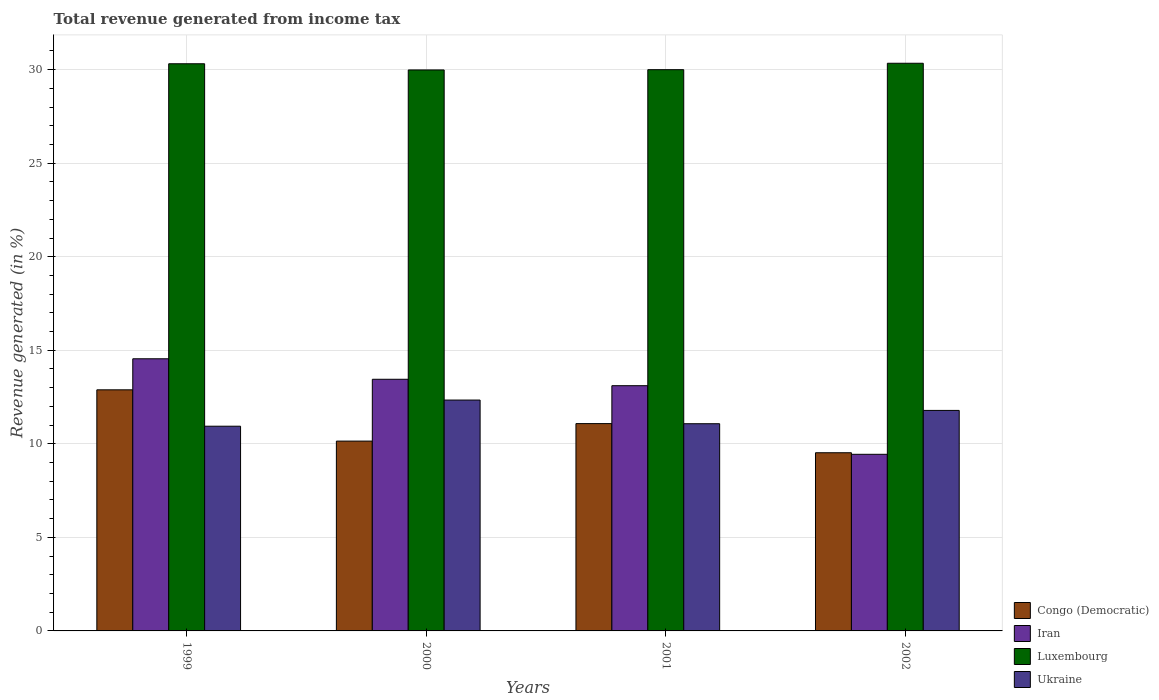How many groups of bars are there?
Your answer should be very brief. 4. Are the number of bars per tick equal to the number of legend labels?
Your answer should be compact. Yes. Are the number of bars on each tick of the X-axis equal?
Your answer should be compact. Yes. What is the label of the 1st group of bars from the left?
Provide a short and direct response. 1999. What is the total revenue generated in Luxembourg in 2002?
Your answer should be very brief. 30.34. Across all years, what is the maximum total revenue generated in Congo (Democratic)?
Your response must be concise. 12.89. Across all years, what is the minimum total revenue generated in Ukraine?
Offer a very short reply. 10.94. In which year was the total revenue generated in Ukraine maximum?
Offer a terse response. 2000. What is the total total revenue generated in Ukraine in the graph?
Provide a short and direct response. 46.14. What is the difference between the total revenue generated in Iran in 1999 and that in 2002?
Ensure brevity in your answer.  5.11. What is the difference between the total revenue generated in Iran in 2000 and the total revenue generated in Congo (Democratic) in 1999?
Provide a succinct answer. 0.56. What is the average total revenue generated in Congo (Democratic) per year?
Your answer should be very brief. 10.91. In the year 1999, what is the difference between the total revenue generated in Iran and total revenue generated in Luxembourg?
Give a very brief answer. -15.77. In how many years, is the total revenue generated in Luxembourg greater than 15 %?
Offer a very short reply. 4. What is the ratio of the total revenue generated in Iran in 2001 to that in 2002?
Give a very brief answer. 1.39. Is the total revenue generated in Luxembourg in 2000 less than that in 2001?
Your answer should be very brief. Yes. Is the difference between the total revenue generated in Iran in 2000 and 2002 greater than the difference between the total revenue generated in Luxembourg in 2000 and 2002?
Offer a very short reply. Yes. What is the difference between the highest and the second highest total revenue generated in Luxembourg?
Your answer should be compact. 0.03. What is the difference between the highest and the lowest total revenue generated in Iran?
Provide a short and direct response. 5.11. Is the sum of the total revenue generated in Luxembourg in 2000 and 2001 greater than the maximum total revenue generated in Iran across all years?
Provide a succinct answer. Yes. What does the 2nd bar from the left in 1999 represents?
Ensure brevity in your answer.  Iran. What does the 3rd bar from the right in 2002 represents?
Offer a very short reply. Iran. Are all the bars in the graph horizontal?
Provide a short and direct response. No. How many years are there in the graph?
Offer a terse response. 4. Where does the legend appear in the graph?
Give a very brief answer. Bottom right. How many legend labels are there?
Provide a short and direct response. 4. What is the title of the graph?
Your answer should be very brief. Total revenue generated from income tax. Does "Guinea" appear as one of the legend labels in the graph?
Provide a succinct answer. No. What is the label or title of the X-axis?
Provide a short and direct response. Years. What is the label or title of the Y-axis?
Offer a terse response. Revenue generated (in %). What is the Revenue generated (in %) of Congo (Democratic) in 1999?
Your answer should be very brief. 12.89. What is the Revenue generated (in %) of Iran in 1999?
Your answer should be very brief. 14.55. What is the Revenue generated (in %) in Luxembourg in 1999?
Provide a short and direct response. 30.32. What is the Revenue generated (in %) of Ukraine in 1999?
Ensure brevity in your answer.  10.94. What is the Revenue generated (in %) in Congo (Democratic) in 2000?
Your answer should be compact. 10.15. What is the Revenue generated (in %) of Iran in 2000?
Your answer should be compact. 13.45. What is the Revenue generated (in %) of Luxembourg in 2000?
Your response must be concise. 29.98. What is the Revenue generated (in %) in Ukraine in 2000?
Make the answer very short. 12.34. What is the Revenue generated (in %) of Congo (Democratic) in 2001?
Provide a succinct answer. 11.08. What is the Revenue generated (in %) in Iran in 2001?
Provide a succinct answer. 13.11. What is the Revenue generated (in %) of Luxembourg in 2001?
Provide a short and direct response. 30. What is the Revenue generated (in %) of Ukraine in 2001?
Provide a short and direct response. 11.07. What is the Revenue generated (in %) of Congo (Democratic) in 2002?
Give a very brief answer. 9.52. What is the Revenue generated (in %) in Iran in 2002?
Offer a very short reply. 9.44. What is the Revenue generated (in %) in Luxembourg in 2002?
Offer a very short reply. 30.34. What is the Revenue generated (in %) in Ukraine in 2002?
Give a very brief answer. 11.79. Across all years, what is the maximum Revenue generated (in %) of Congo (Democratic)?
Offer a very short reply. 12.89. Across all years, what is the maximum Revenue generated (in %) in Iran?
Offer a very short reply. 14.55. Across all years, what is the maximum Revenue generated (in %) of Luxembourg?
Give a very brief answer. 30.34. Across all years, what is the maximum Revenue generated (in %) in Ukraine?
Offer a very short reply. 12.34. Across all years, what is the minimum Revenue generated (in %) of Congo (Democratic)?
Provide a succinct answer. 9.52. Across all years, what is the minimum Revenue generated (in %) in Iran?
Your response must be concise. 9.44. Across all years, what is the minimum Revenue generated (in %) of Luxembourg?
Keep it short and to the point. 29.98. Across all years, what is the minimum Revenue generated (in %) of Ukraine?
Provide a short and direct response. 10.94. What is the total Revenue generated (in %) of Congo (Democratic) in the graph?
Ensure brevity in your answer.  43.64. What is the total Revenue generated (in %) of Iran in the graph?
Ensure brevity in your answer.  50.54. What is the total Revenue generated (in %) in Luxembourg in the graph?
Provide a succinct answer. 120.64. What is the total Revenue generated (in %) of Ukraine in the graph?
Keep it short and to the point. 46.14. What is the difference between the Revenue generated (in %) of Congo (Democratic) in 1999 and that in 2000?
Your response must be concise. 2.74. What is the difference between the Revenue generated (in %) of Iran in 1999 and that in 2000?
Provide a succinct answer. 1.1. What is the difference between the Revenue generated (in %) of Luxembourg in 1999 and that in 2000?
Make the answer very short. 0.33. What is the difference between the Revenue generated (in %) of Ukraine in 1999 and that in 2000?
Give a very brief answer. -1.4. What is the difference between the Revenue generated (in %) in Congo (Democratic) in 1999 and that in 2001?
Give a very brief answer. 1.81. What is the difference between the Revenue generated (in %) in Iran in 1999 and that in 2001?
Your answer should be very brief. 1.44. What is the difference between the Revenue generated (in %) in Luxembourg in 1999 and that in 2001?
Offer a terse response. 0.32. What is the difference between the Revenue generated (in %) of Ukraine in 1999 and that in 2001?
Your answer should be compact. -0.13. What is the difference between the Revenue generated (in %) in Congo (Democratic) in 1999 and that in 2002?
Offer a terse response. 3.36. What is the difference between the Revenue generated (in %) in Iran in 1999 and that in 2002?
Your response must be concise. 5.11. What is the difference between the Revenue generated (in %) of Luxembourg in 1999 and that in 2002?
Provide a succinct answer. -0.03. What is the difference between the Revenue generated (in %) in Ukraine in 1999 and that in 2002?
Offer a very short reply. -0.84. What is the difference between the Revenue generated (in %) in Congo (Democratic) in 2000 and that in 2001?
Make the answer very short. -0.94. What is the difference between the Revenue generated (in %) in Iran in 2000 and that in 2001?
Give a very brief answer. 0.34. What is the difference between the Revenue generated (in %) of Luxembourg in 2000 and that in 2001?
Ensure brevity in your answer.  -0.01. What is the difference between the Revenue generated (in %) in Ukraine in 2000 and that in 2001?
Offer a very short reply. 1.27. What is the difference between the Revenue generated (in %) of Congo (Democratic) in 2000 and that in 2002?
Your answer should be compact. 0.62. What is the difference between the Revenue generated (in %) of Iran in 2000 and that in 2002?
Offer a terse response. 4.01. What is the difference between the Revenue generated (in %) of Luxembourg in 2000 and that in 2002?
Make the answer very short. -0.36. What is the difference between the Revenue generated (in %) in Ukraine in 2000 and that in 2002?
Provide a succinct answer. 0.55. What is the difference between the Revenue generated (in %) of Congo (Democratic) in 2001 and that in 2002?
Offer a very short reply. 1.56. What is the difference between the Revenue generated (in %) in Iran in 2001 and that in 2002?
Give a very brief answer. 3.67. What is the difference between the Revenue generated (in %) in Luxembourg in 2001 and that in 2002?
Your answer should be very brief. -0.34. What is the difference between the Revenue generated (in %) of Ukraine in 2001 and that in 2002?
Your answer should be very brief. -0.71. What is the difference between the Revenue generated (in %) of Congo (Democratic) in 1999 and the Revenue generated (in %) of Iran in 2000?
Give a very brief answer. -0.56. What is the difference between the Revenue generated (in %) in Congo (Democratic) in 1999 and the Revenue generated (in %) in Luxembourg in 2000?
Keep it short and to the point. -17.1. What is the difference between the Revenue generated (in %) of Congo (Democratic) in 1999 and the Revenue generated (in %) of Ukraine in 2000?
Offer a terse response. 0.55. What is the difference between the Revenue generated (in %) in Iran in 1999 and the Revenue generated (in %) in Luxembourg in 2000?
Give a very brief answer. -15.44. What is the difference between the Revenue generated (in %) of Iran in 1999 and the Revenue generated (in %) of Ukraine in 2000?
Offer a very short reply. 2.21. What is the difference between the Revenue generated (in %) of Luxembourg in 1999 and the Revenue generated (in %) of Ukraine in 2000?
Provide a succinct answer. 17.97. What is the difference between the Revenue generated (in %) in Congo (Democratic) in 1999 and the Revenue generated (in %) in Iran in 2001?
Keep it short and to the point. -0.22. What is the difference between the Revenue generated (in %) in Congo (Democratic) in 1999 and the Revenue generated (in %) in Luxembourg in 2001?
Give a very brief answer. -17.11. What is the difference between the Revenue generated (in %) in Congo (Democratic) in 1999 and the Revenue generated (in %) in Ukraine in 2001?
Give a very brief answer. 1.81. What is the difference between the Revenue generated (in %) in Iran in 1999 and the Revenue generated (in %) in Luxembourg in 2001?
Your answer should be very brief. -15.45. What is the difference between the Revenue generated (in %) of Iran in 1999 and the Revenue generated (in %) of Ukraine in 2001?
Your response must be concise. 3.47. What is the difference between the Revenue generated (in %) of Luxembourg in 1999 and the Revenue generated (in %) of Ukraine in 2001?
Ensure brevity in your answer.  19.24. What is the difference between the Revenue generated (in %) in Congo (Democratic) in 1999 and the Revenue generated (in %) in Iran in 2002?
Your answer should be very brief. 3.45. What is the difference between the Revenue generated (in %) of Congo (Democratic) in 1999 and the Revenue generated (in %) of Luxembourg in 2002?
Make the answer very short. -17.45. What is the difference between the Revenue generated (in %) in Congo (Democratic) in 1999 and the Revenue generated (in %) in Ukraine in 2002?
Your response must be concise. 1.1. What is the difference between the Revenue generated (in %) in Iran in 1999 and the Revenue generated (in %) in Luxembourg in 2002?
Your answer should be very brief. -15.8. What is the difference between the Revenue generated (in %) in Iran in 1999 and the Revenue generated (in %) in Ukraine in 2002?
Make the answer very short. 2.76. What is the difference between the Revenue generated (in %) of Luxembourg in 1999 and the Revenue generated (in %) of Ukraine in 2002?
Your answer should be very brief. 18.53. What is the difference between the Revenue generated (in %) of Congo (Democratic) in 2000 and the Revenue generated (in %) of Iran in 2001?
Your answer should be very brief. -2.96. What is the difference between the Revenue generated (in %) in Congo (Democratic) in 2000 and the Revenue generated (in %) in Luxembourg in 2001?
Your answer should be very brief. -19.85. What is the difference between the Revenue generated (in %) in Congo (Democratic) in 2000 and the Revenue generated (in %) in Ukraine in 2001?
Your response must be concise. -0.93. What is the difference between the Revenue generated (in %) in Iran in 2000 and the Revenue generated (in %) in Luxembourg in 2001?
Your answer should be compact. -16.55. What is the difference between the Revenue generated (in %) of Iran in 2000 and the Revenue generated (in %) of Ukraine in 2001?
Provide a succinct answer. 2.38. What is the difference between the Revenue generated (in %) of Luxembourg in 2000 and the Revenue generated (in %) of Ukraine in 2001?
Give a very brief answer. 18.91. What is the difference between the Revenue generated (in %) of Congo (Democratic) in 2000 and the Revenue generated (in %) of Iran in 2002?
Give a very brief answer. 0.71. What is the difference between the Revenue generated (in %) in Congo (Democratic) in 2000 and the Revenue generated (in %) in Luxembourg in 2002?
Make the answer very short. -20.2. What is the difference between the Revenue generated (in %) in Congo (Democratic) in 2000 and the Revenue generated (in %) in Ukraine in 2002?
Provide a succinct answer. -1.64. What is the difference between the Revenue generated (in %) of Iran in 2000 and the Revenue generated (in %) of Luxembourg in 2002?
Give a very brief answer. -16.89. What is the difference between the Revenue generated (in %) in Iran in 2000 and the Revenue generated (in %) in Ukraine in 2002?
Offer a very short reply. 1.66. What is the difference between the Revenue generated (in %) of Luxembourg in 2000 and the Revenue generated (in %) of Ukraine in 2002?
Provide a short and direct response. 18.2. What is the difference between the Revenue generated (in %) of Congo (Democratic) in 2001 and the Revenue generated (in %) of Iran in 2002?
Keep it short and to the point. 1.64. What is the difference between the Revenue generated (in %) in Congo (Democratic) in 2001 and the Revenue generated (in %) in Luxembourg in 2002?
Make the answer very short. -19.26. What is the difference between the Revenue generated (in %) of Congo (Democratic) in 2001 and the Revenue generated (in %) of Ukraine in 2002?
Keep it short and to the point. -0.71. What is the difference between the Revenue generated (in %) in Iran in 2001 and the Revenue generated (in %) in Luxembourg in 2002?
Provide a short and direct response. -17.23. What is the difference between the Revenue generated (in %) in Iran in 2001 and the Revenue generated (in %) in Ukraine in 2002?
Keep it short and to the point. 1.32. What is the difference between the Revenue generated (in %) of Luxembourg in 2001 and the Revenue generated (in %) of Ukraine in 2002?
Provide a succinct answer. 18.21. What is the average Revenue generated (in %) of Congo (Democratic) per year?
Your response must be concise. 10.91. What is the average Revenue generated (in %) in Iran per year?
Provide a short and direct response. 12.64. What is the average Revenue generated (in %) in Luxembourg per year?
Ensure brevity in your answer.  30.16. What is the average Revenue generated (in %) in Ukraine per year?
Your response must be concise. 11.54. In the year 1999, what is the difference between the Revenue generated (in %) of Congo (Democratic) and Revenue generated (in %) of Iran?
Ensure brevity in your answer.  -1.66. In the year 1999, what is the difference between the Revenue generated (in %) in Congo (Democratic) and Revenue generated (in %) in Luxembourg?
Offer a very short reply. -17.43. In the year 1999, what is the difference between the Revenue generated (in %) of Congo (Democratic) and Revenue generated (in %) of Ukraine?
Offer a very short reply. 1.95. In the year 1999, what is the difference between the Revenue generated (in %) in Iran and Revenue generated (in %) in Luxembourg?
Your response must be concise. -15.77. In the year 1999, what is the difference between the Revenue generated (in %) of Iran and Revenue generated (in %) of Ukraine?
Provide a short and direct response. 3.6. In the year 1999, what is the difference between the Revenue generated (in %) in Luxembourg and Revenue generated (in %) in Ukraine?
Make the answer very short. 19.37. In the year 2000, what is the difference between the Revenue generated (in %) in Congo (Democratic) and Revenue generated (in %) in Iran?
Offer a very short reply. -3.3. In the year 2000, what is the difference between the Revenue generated (in %) in Congo (Democratic) and Revenue generated (in %) in Luxembourg?
Give a very brief answer. -19.84. In the year 2000, what is the difference between the Revenue generated (in %) of Congo (Democratic) and Revenue generated (in %) of Ukraine?
Ensure brevity in your answer.  -2.19. In the year 2000, what is the difference between the Revenue generated (in %) in Iran and Revenue generated (in %) in Luxembourg?
Offer a terse response. -16.53. In the year 2000, what is the difference between the Revenue generated (in %) in Iran and Revenue generated (in %) in Ukraine?
Your answer should be compact. 1.11. In the year 2000, what is the difference between the Revenue generated (in %) in Luxembourg and Revenue generated (in %) in Ukraine?
Your answer should be compact. 17.64. In the year 2001, what is the difference between the Revenue generated (in %) in Congo (Democratic) and Revenue generated (in %) in Iran?
Your answer should be very brief. -2.03. In the year 2001, what is the difference between the Revenue generated (in %) in Congo (Democratic) and Revenue generated (in %) in Luxembourg?
Make the answer very short. -18.92. In the year 2001, what is the difference between the Revenue generated (in %) in Congo (Democratic) and Revenue generated (in %) in Ukraine?
Keep it short and to the point. 0.01. In the year 2001, what is the difference between the Revenue generated (in %) of Iran and Revenue generated (in %) of Luxembourg?
Give a very brief answer. -16.89. In the year 2001, what is the difference between the Revenue generated (in %) of Iran and Revenue generated (in %) of Ukraine?
Offer a terse response. 2.03. In the year 2001, what is the difference between the Revenue generated (in %) of Luxembourg and Revenue generated (in %) of Ukraine?
Make the answer very short. 18.92. In the year 2002, what is the difference between the Revenue generated (in %) in Congo (Democratic) and Revenue generated (in %) in Iran?
Offer a very short reply. 0.08. In the year 2002, what is the difference between the Revenue generated (in %) in Congo (Democratic) and Revenue generated (in %) in Luxembourg?
Give a very brief answer. -20.82. In the year 2002, what is the difference between the Revenue generated (in %) in Congo (Democratic) and Revenue generated (in %) in Ukraine?
Keep it short and to the point. -2.26. In the year 2002, what is the difference between the Revenue generated (in %) of Iran and Revenue generated (in %) of Luxembourg?
Make the answer very short. -20.9. In the year 2002, what is the difference between the Revenue generated (in %) of Iran and Revenue generated (in %) of Ukraine?
Give a very brief answer. -2.35. In the year 2002, what is the difference between the Revenue generated (in %) in Luxembourg and Revenue generated (in %) in Ukraine?
Offer a very short reply. 18.56. What is the ratio of the Revenue generated (in %) in Congo (Democratic) in 1999 to that in 2000?
Your answer should be compact. 1.27. What is the ratio of the Revenue generated (in %) of Iran in 1999 to that in 2000?
Provide a short and direct response. 1.08. What is the ratio of the Revenue generated (in %) in Ukraine in 1999 to that in 2000?
Give a very brief answer. 0.89. What is the ratio of the Revenue generated (in %) in Congo (Democratic) in 1999 to that in 2001?
Provide a succinct answer. 1.16. What is the ratio of the Revenue generated (in %) in Iran in 1999 to that in 2001?
Ensure brevity in your answer.  1.11. What is the ratio of the Revenue generated (in %) in Luxembourg in 1999 to that in 2001?
Offer a very short reply. 1.01. What is the ratio of the Revenue generated (in %) of Ukraine in 1999 to that in 2001?
Make the answer very short. 0.99. What is the ratio of the Revenue generated (in %) in Congo (Democratic) in 1999 to that in 2002?
Your response must be concise. 1.35. What is the ratio of the Revenue generated (in %) in Iran in 1999 to that in 2002?
Offer a very short reply. 1.54. What is the ratio of the Revenue generated (in %) in Ukraine in 1999 to that in 2002?
Offer a terse response. 0.93. What is the ratio of the Revenue generated (in %) of Congo (Democratic) in 2000 to that in 2001?
Provide a short and direct response. 0.92. What is the ratio of the Revenue generated (in %) of Iran in 2000 to that in 2001?
Your answer should be compact. 1.03. What is the ratio of the Revenue generated (in %) of Luxembourg in 2000 to that in 2001?
Provide a short and direct response. 1. What is the ratio of the Revenue generated (in %) in Ukraine in 2000 to that in 2001?
Provide a succinct answer. 1.11. What is the ratio of the Revenue generated (in %) in Congo (Democratic) in 2000 to that in 2002?
Your answer should be compact. 1.07. What is the ratio of the Revenue generated (in %) in Iran in 2000 to that in 2002?
Give a very brief answer. 1.42. What is the ratio of the Revenue generated (in %) in Ukraine in 2000 to that in 2002?
Provide a succinct answer. 1.05. What is the ratio of the Revenue generated (in %) of Congo (Democratic) in 2001 to that in 2002?
Ensure brevity in your answer.  1.16. What is the ratio of the Revenue generated (in %) of Iran in 2001 to that in 2002?
Ensure brevity in your answer.  1.39. What is the ratio of the Revenue generated (in %) of Luxembourg in 2001 to that in 2002?
Offer a terse response. 0.99. What is the ratio of the Revenue generated (in %) in Ukraine in 2001 to that in 2002?
Keep it short and to the point. 0.94. What is the difference between the highest and the second highest Revenue generated (in %) in Congo (Democratic)?
Keep it short and to the point. 1.81. What is the difference between the highest and the second highest Revenue generated (in %) of Iran?
Make the answer very short. 1.1. What is the difference between the highest and the second highest Revenue generated (in %) of Luxembourg?
Keep it short and to the point. 0.03. What is the difference between the highest and the second highest Revenue generated (in %) in Ukraine?
Your answer should be compact. 0.55. What is the difference between the highest and the lowest Revenue generated (in %) in Congo (Democratic)?
Offer a very short reply. 3.36. What is the difference between the highest and the lowest Revenue generated (in %) of Iran?
Offer a very short reply. 5.11. What is the difference between the highest and the lowest Revenue generated (in %) in Luxembourg?
Your answer should be compact. 0.36. What is the difference between the highest and the lowest Revenue generated (in %) of Ukraine?
Your answer should be compact. 1.4. 